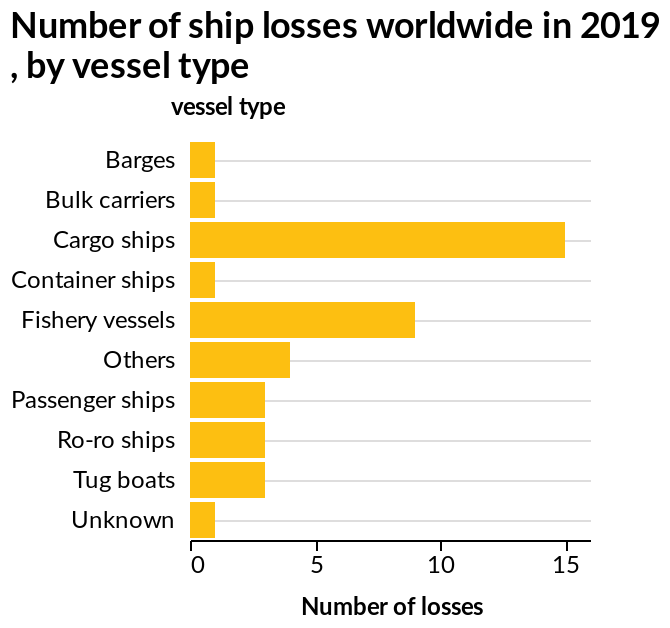<image>
In which year were the ship losses measured? The ship losses were measured in the year 2019. please enumerates aspects of the construction of the chart Number of ship losses worldwide in 2019 , by vessel type is a bar graph. The x-axis shows Number of losses while the y-axis plots vessel type. 